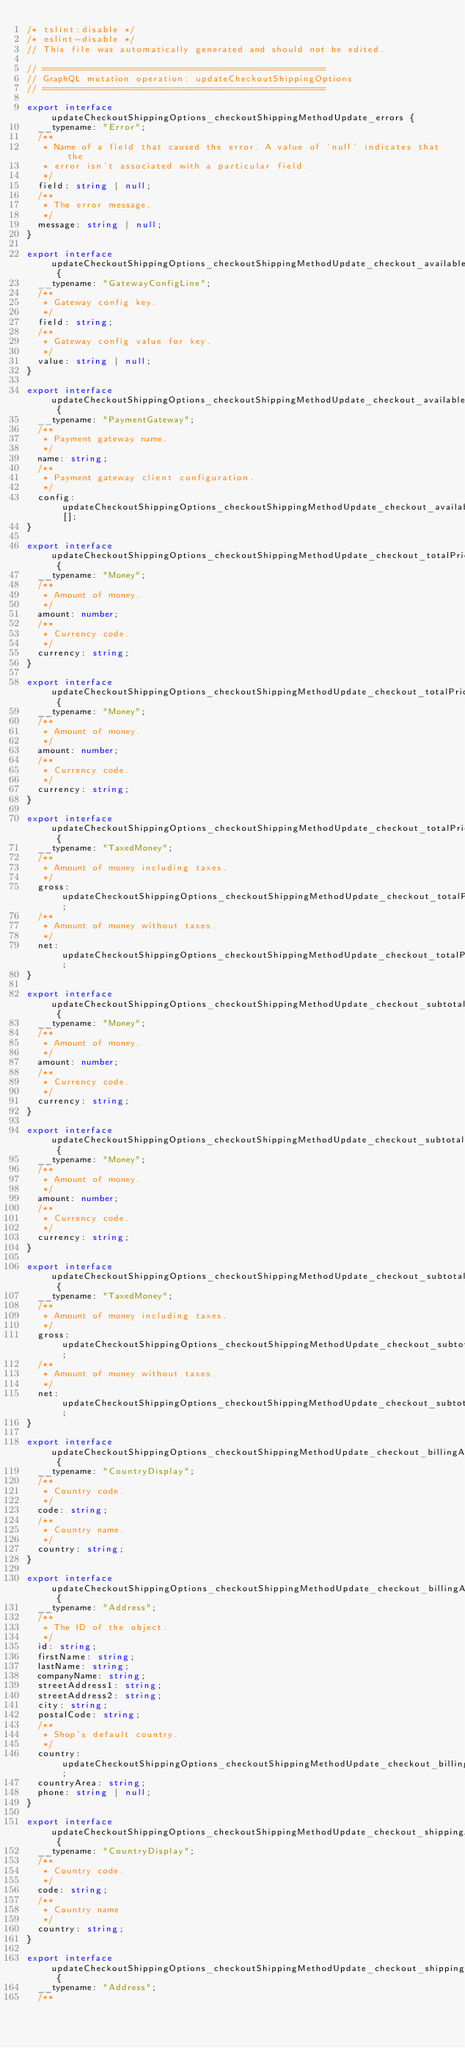Convert code to text. <code><loc_0><loc_0><loc_500><loc_500><_TypeScript_>/* tslint:disable */
/* eslint-disable */
// This file was automatically generated and should not be edited.

// ====================================================
// GraphQL mutation operation: updateCheckoutShippingOptions
// ====================================================

export interface updateCheckoutShippingOptions_checkoutShippingMethodUpdate_errors {
  __typename: "Error";
  /**
   * Name of a field that caused the error. A value of `null` indicates that the
   * error isn't associated with a particular field.
   */
  field: string | null;
  /**
   * The error message.
   */
  message: string | null;
}

export interface updateCheckoutShippingOptions_checkoutShippingMethodUpdate_checkout_availablePaymentGateways_config {
  __typename: "GatewayConfigLine";
  /**
   * Gateway config key.
   */
  field: string;
  /**
   * Gateway config value for key.
   */
  value: string | null;
}

export interface updateCheckoutShippingOptions_checkoutShippingMethodUpdate_checkout_availablePaymentGateways {
  __typename: "PaymentGateway";
  /**
   * Payment gateway name.
   */
  name: string;
  /**
   * Payment gateway client configuration.
   */
  config: updateCheckoutShippingOptions_checkoutShippingMethodUpdate_checkout_availablePaymentGateways_config[];
}

export interface updateCheckoutShippingOptions_checkoutShippingMethodUpdate_checkout_totalPrice_gross {
  __typename: "Money";
  /**
   * Amount of money.
   */
  amount: number;
  /**
   * Currency code.
   */
  currency: string;
}

export interface updateCheckoutShippingOptions_checkoutShippingMethodUpdate_checkout_totalPrice_net {
  __typename: "Money";
  /**
   * Amount of money.
   */
  amount: number;
  /**
   * Currency code.
   */
  currency: string;
}

export interface updateCheckoutShippingOptions_checkoutShippingMethodUpdate_checkout_totalPrice {
  __typename: "TaxedMoney";
  /**
   * Amount of money including taxes.
   */
  gross: updateCheckoutShippingOptions_checkoutShippingMethodUpdate_checkout_totalPrice_gross;
  /**
   * Amount of money without taxes.
   */
  net: updateCheckoutShippingOptions_checkoutShippingMethodUpdate_checkout_totalPrice_net;
}

export interface updateCheckoutShippingOptions_checkoutShippingMethodUpdate_checkout_subtotalPrice_gross {
  __typename: "Money";
  /**
   * Amount of money.
   */
  amount: number;
  /**
   * Currency code.
   */
  currency: string;
}

export interface updateCheckoutShippingOptions_checkoutShippingMethodUpdate_checkout_subtotalPrice_net {
  __typename: "Money";
  /**
   * Amount of money.
   */
  amount: number;
  /**
   * Currency code.
   */
  currency: string;
}

export interface updateCheckoutShippingOptions_checkoutShippingMethodUpdate_checkout_subtotalPrice {
  __typename: "TaxedMoney";
  /**
   * Amount of money including taxes.
   */
  gross: updateCheckoutShippingOptions_checkoutShippingMethodUpdate_checkout_subtotalPrice_gross;
  /**
   * Amount of money without taxes.
   */
  net: updateCheckoutShippingOptions_checkoutShippingMethodUpdate_checkout_subtotalPrice_net;
}

export interface updateCheckoutShippingOptions_checkoutShippingMethodUpdate_checkout_billingAddress_country {
  __typename: "CountryDisplay";
  /**
   * Country code.
   */
  code: string;
  /**
   * Country name.
   */
  country: string;
}

export interface updateCheckoutShippingOptions_checkoutShippingMethodUpdate_checkout_billingAddress {
  __typename: "Address";
  /**
   * The ID of the object.
   */
  id: string;
  firstName: string;
  lastName: string;
  companyName: string;
  streetAddress1: string;
  streetAddress2: string;
  city: string;
  postalCode: string;
  /**
   * Shop's default country.
   */
  country: updateCheckoutShippingOptions_checkoutShippingMethodUpdate_checkout_billingAddress_country;
  countryArea: string;
  phone: string | null;
}

export interface updateCheckoutShippingOptions_checkoutShippingMethodUpdate_checkout_shippingAddress_country {
  __typename: "CountryDisplay";
  /**
   * Country code.
   */
  code: string;
  /**
   * Country name.
   */
  country: string;
}

export interface updateCheckoutShippingOptions_checkoutShippingMethodUpdate_checkout_shippingAddress {
  __typename: "Address";
  /**</code> 